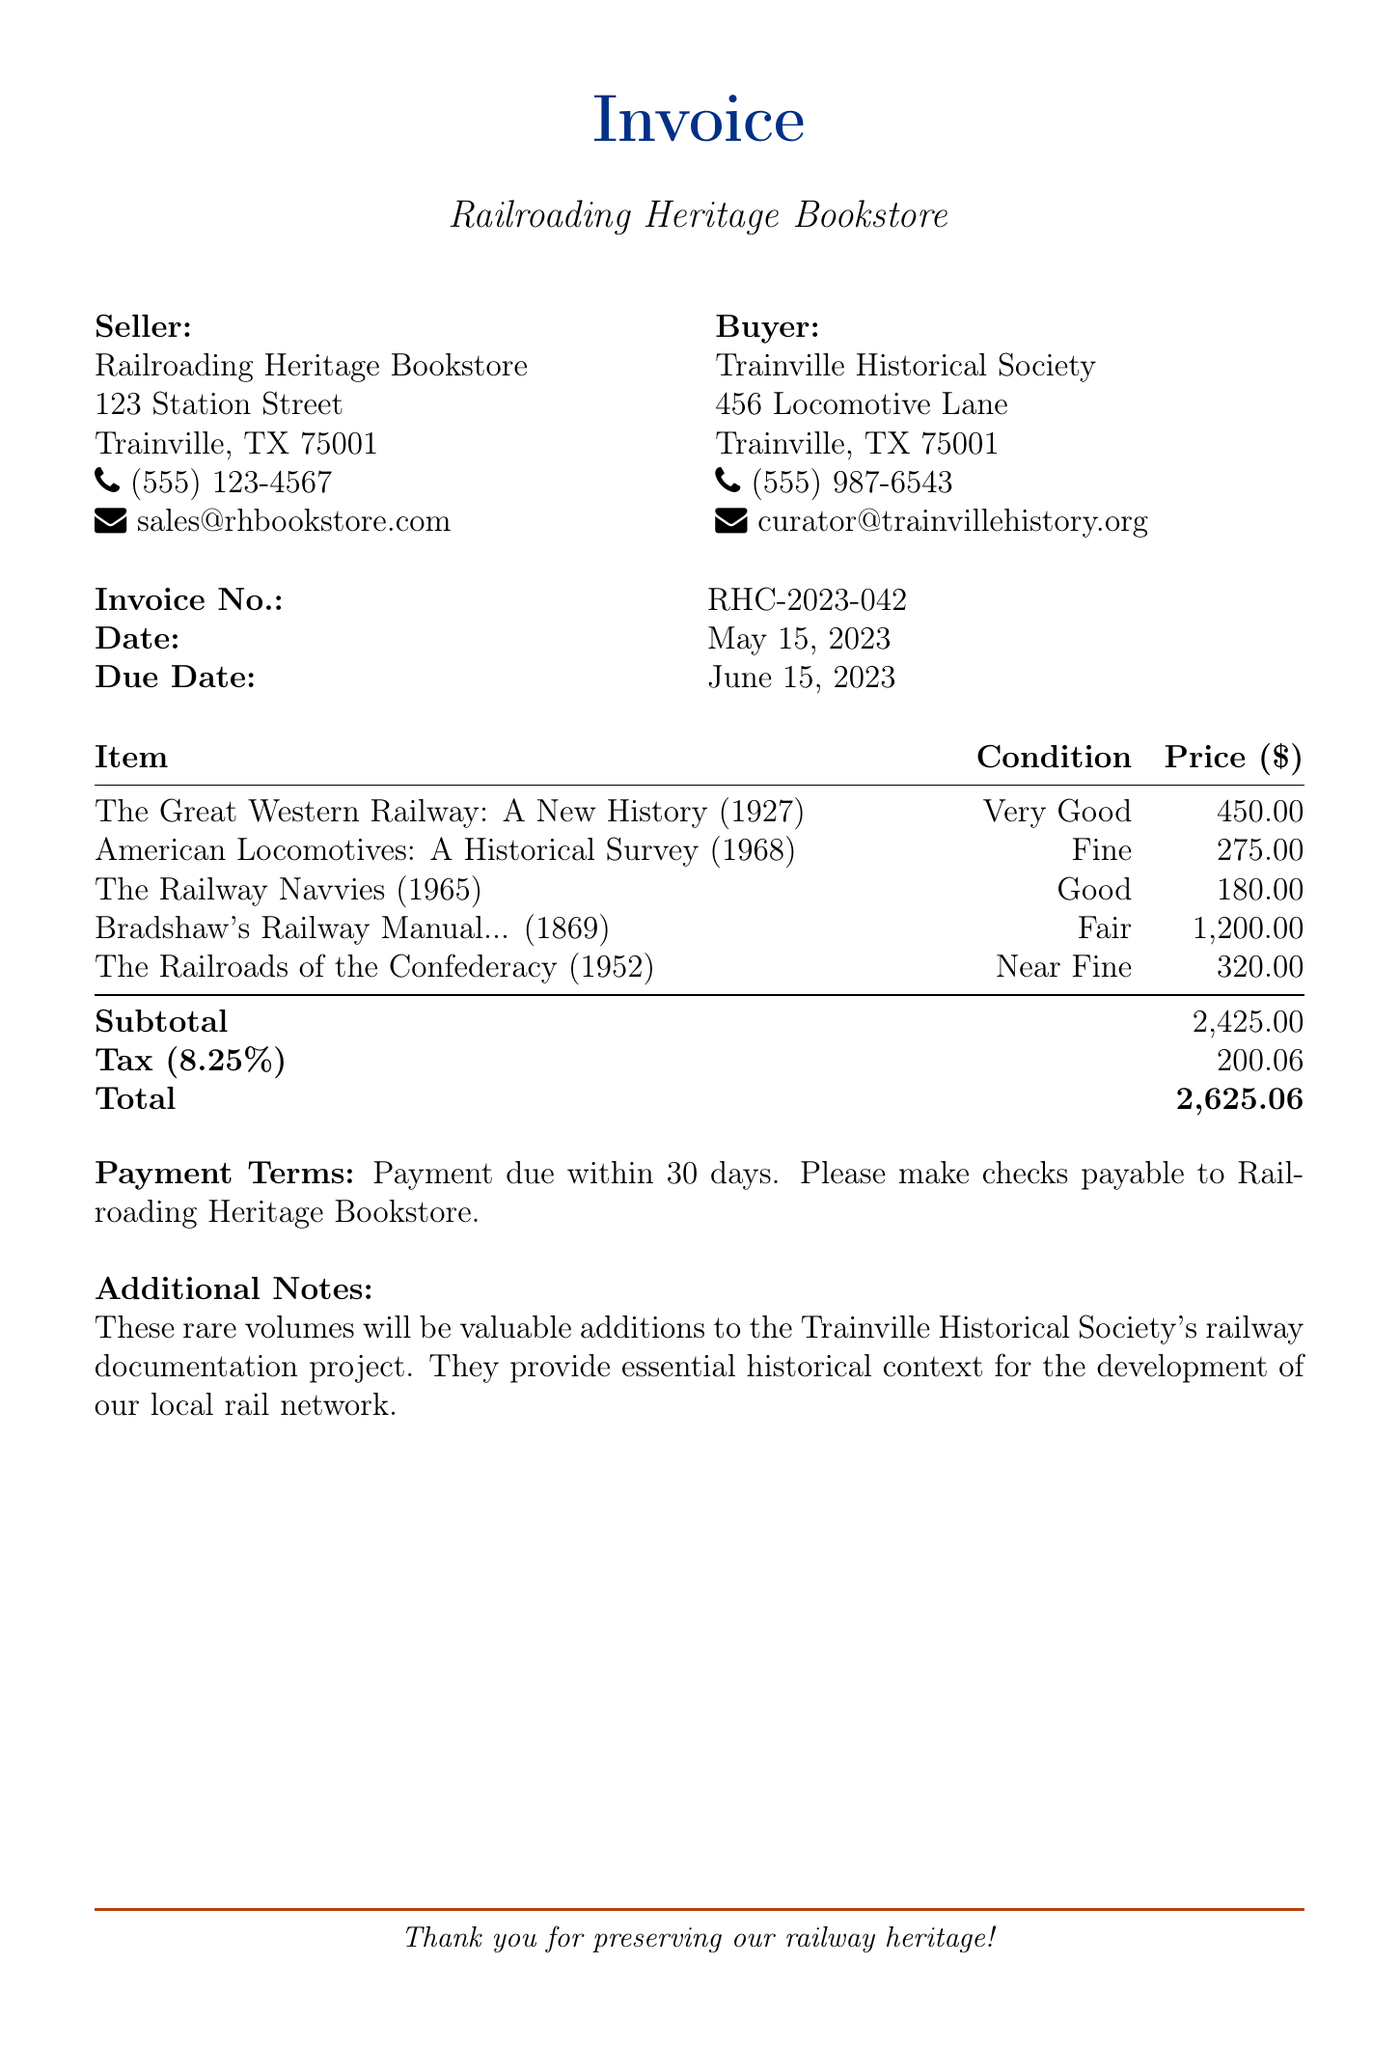What is the invoice number? The invoice number is specified in the document under "Invoice No.," which is RHC-2023-042.
Answer: RHC-2023-042 Who is the seller? The seller's name and details are provided at the top of the document, identifying the Railroading Heritage Bookstore as the seller.
Answer: Railroading Heritage Bookstore What is the total amount due? The total amount due is shown at the bottom of the invoice and includes subtotal, tax, and is marked as Total.
Answer: 2,625.06 What is the condition of "The Railway Navvies"? The condition is listed alongside the item and is classified under the column for Condition.
Answer: Good What is the publication year of "American Locomotives"? The publication year is included in parentheses next to the title of the book in the itemized list.
Answer: 1968 What is the tax percentage applied? The tax percentage is indicated in the document and is noted under Tax after the subtotal.
Answer: 8.25% How many days is payment due? The payment terms specify the due period after the invoice date, found under Payment Terms.
Answer: 30 days What additional note is provided? The additional note elaborates on the importance of the volumes and is listed at the end of the document under Additional Notes.
Answer: Essential historical context What is the address of the buyer? The address is presented in the buyer's information section of the document.
Answer: 456 Locomotive Lane, Trainville, TX 75001 What is the subtotal amount? The subtotal is clearly stated in the itemized list, representing the total before tax.
Answer: 2,425.00 